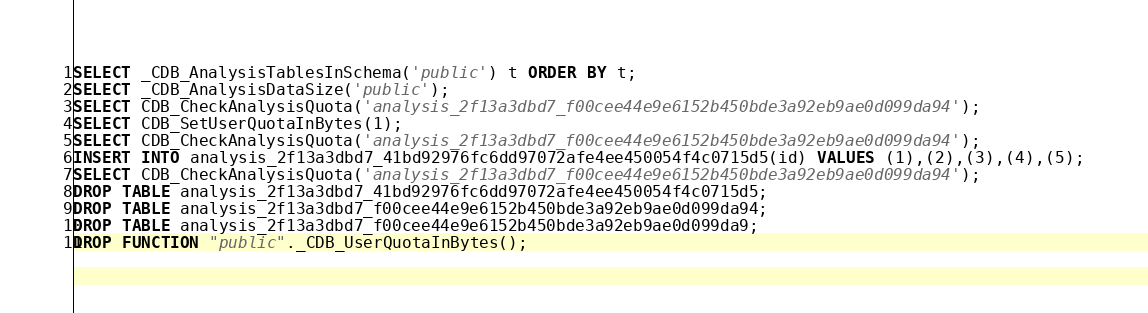Convert code to text. <code><loc_0><loc_0><loc_500><loc_500><_SQL_>SELECT _CDB_AnalysisTablesInSchema('public') t ORDER BY t;
SELECT _CDB_AnalysisDataSize('public');
SELECT CDB_CheckAnalysisQuota('analysis_2f13a3dbd7_f00cee44e9e6152b450bde3a92eb9ae0d099da94');
SELECT CDB_SetUserQuotaInBytes(1);
SELECT CDB_CheckAnalysisQuota('analysis_2f13a3dbd7_f00cee44e9e6152b450bde3a92eb9ae0d099da94');
INSERT INTO analysis_2f13a3dbd7_41bd92976fc6dd97072afe4ee450054f4c0715d5(id) VALUES (1),(2),(3),(4),(5);
SELECT CDB_CheckAnalysisQuota('analysis_2f13a3dbd7_f00cee44e9e6152b450bde3a92eb9ae0d099da94');
DROP TABLE analysis_2f13a3dbd7_41bd92976fc6dd97072afe4ee450054f4c0715d5;
DROP TABLE analysis_2f13a3dbd7_f00cee44e9e6152b450bde3a92eb9ae0d099da94;
DROP TABLE analysis_2f13a3dbd7_f00cee44e9e6152b450bde3a92eb9ae0d099da9;
DROP FUNCTION "public"._CDB_UserQuotaInBytes();
</code> 